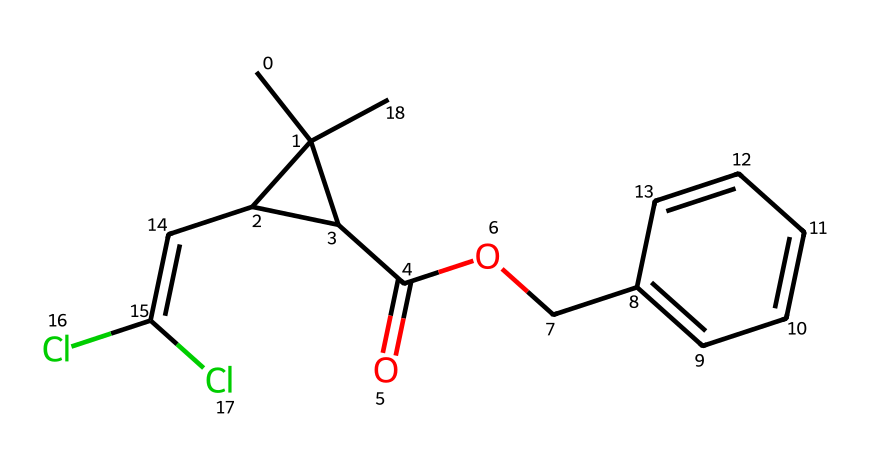What is the chemical name of the compound represented by this SMILES? The SMILES representation corresponds to a structure, which can be translated to its name. From the SMILES, we identify the groups and elements present. The name derived from these components gives us 'permethrin'.
Answer: permethrin How many carbon atoms are present in this chemical structure? A visual inspection of the SMILES string shows multiple instances of 'C', representing carbon atoms. Counting each 'C' in the structure reveals there are 15 carbon atoms in total.
Answer: 15 What functional group is present in this molecule? Looking at the SMILES, we can identify that the part 'C(=O)' indicates a carbonyl group, and 'O' attached to it signifies an ester functional group. Thus, the primary functional group in this molecule is an ester.
Answer: ester What is the total number of chlorine atoms in this structure? Within the SMILES representation, we see 'Cl' present in two occurrences, indicating the presence of two chlorine atoms in the chemical structure.
Answer: 2 What type of compound is permethrin classified as based on its structure? Analyzing the structure, the presence of multiple carbon atoms, additional functional groups, and its application as an insecticide categorizes permethrin as an organochlorine compound.
Answer: organochlorine What is the molecular formula for permethrin based on the structure? By analyzing the chemical structure and tallying the number of each type of atom represented, we arrive at the molecular formula C15H14Cl2O3 for permethrin.
Answer: C15H14Cl2O3 Which part of permethrin is responsible for its insecticidal properties? The presence of an ester linkage and halogenated (chlorinated) aromatic system often enhances toxicity to pests, which in the structure corresponds to the 'C=C(Cl)Cl' part. This structure aids in the molecule’s effectiveness as an insecticide.
Answer: C=C(Cl)Cl 